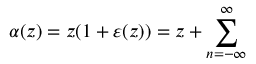Convert formula to latex. <formula><loc_0><loc_0><loc_500><loc_500>\alpha ( z ) = z ( 1 + \varepsilon ( z ) ) = z + \sum _ { n = - \infty } ^ { \infty }</formula> 